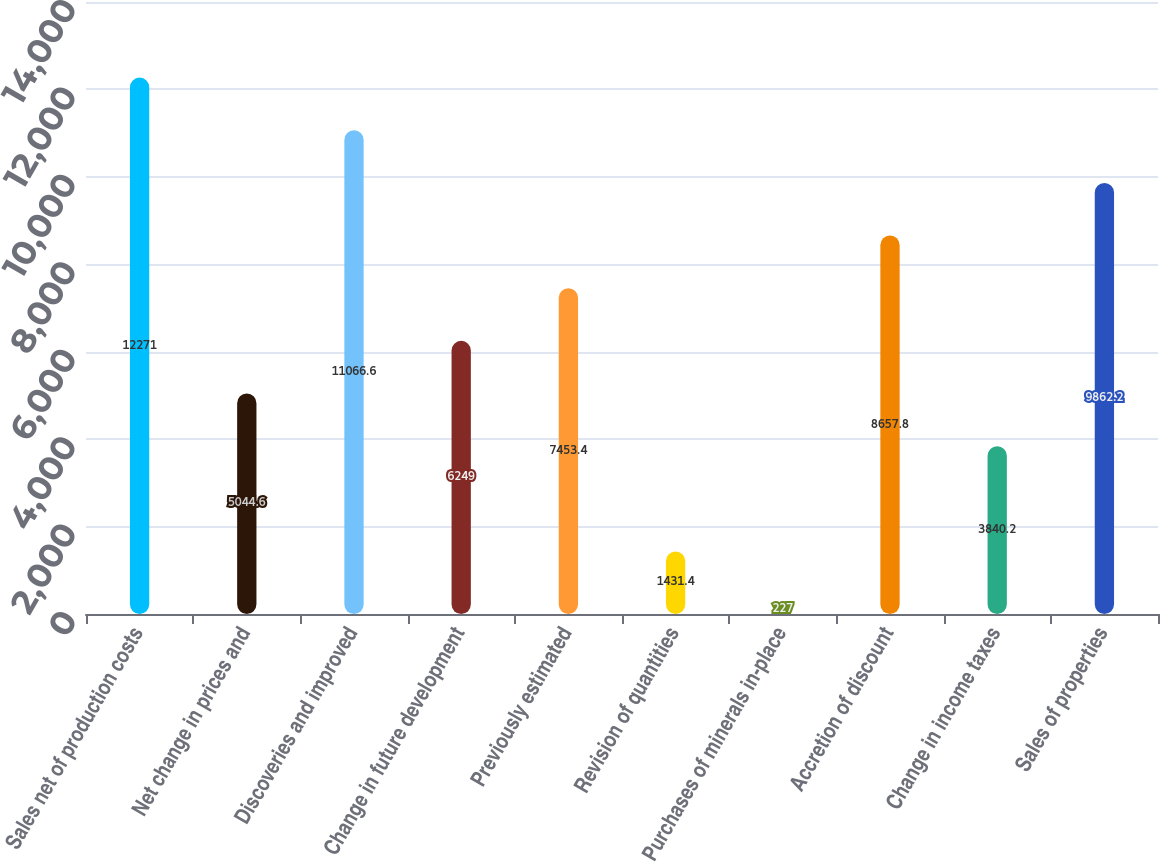Convert chart. <chart><loc_0><loc_0><loc_500><loc_500><bar_chart><fcel>Sales net of production costs<fcel>Net change in prices and<fcel>Discoveries and improved<fcel>Change in future development<fcel>Previously estimated<fcel>Revision of quantities<fcel>Purchases of minerals in-place<fcel>Accretion of discount<fcel>Change in income taxes<fcel>Sales of properties<nl><fcel>12271<fcel>5044.6<fcel>11066.6<fcel>6249<fcel>7453.4<fcel>1431.4<fcel>227<fcel>8657.8<fcel>3840.2<fcel>9862.2<nl></chart> 